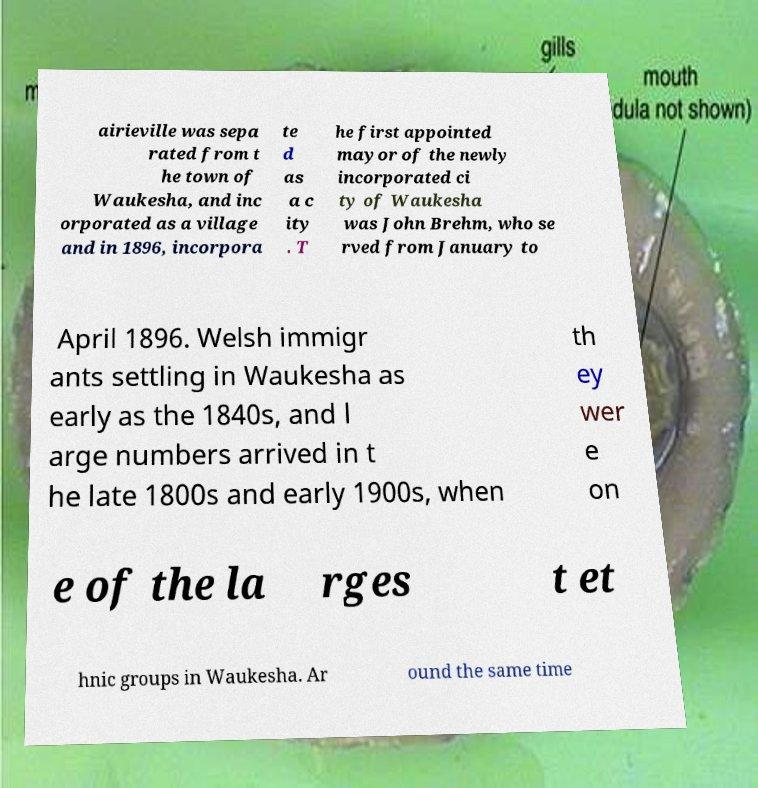Please read and relay the text visible in this image. What does it say? airieville was sepa rated from t he town of Waukesha, and inc orporated as a village and in 1896, incorpora te d as a c ity . T he first appointed mayor of the newly incorporated ci ty of Waukesha was John Brehm, who se rved from January to April 1896. Welsh immigr ants settling in Waukesha as early as the 1840s, and l arge numbers arrived in t he late 1800s and early 1900s, when th ey wer e on e of the la rges t et hnic groups in Waukesha. Ar ound the same time 